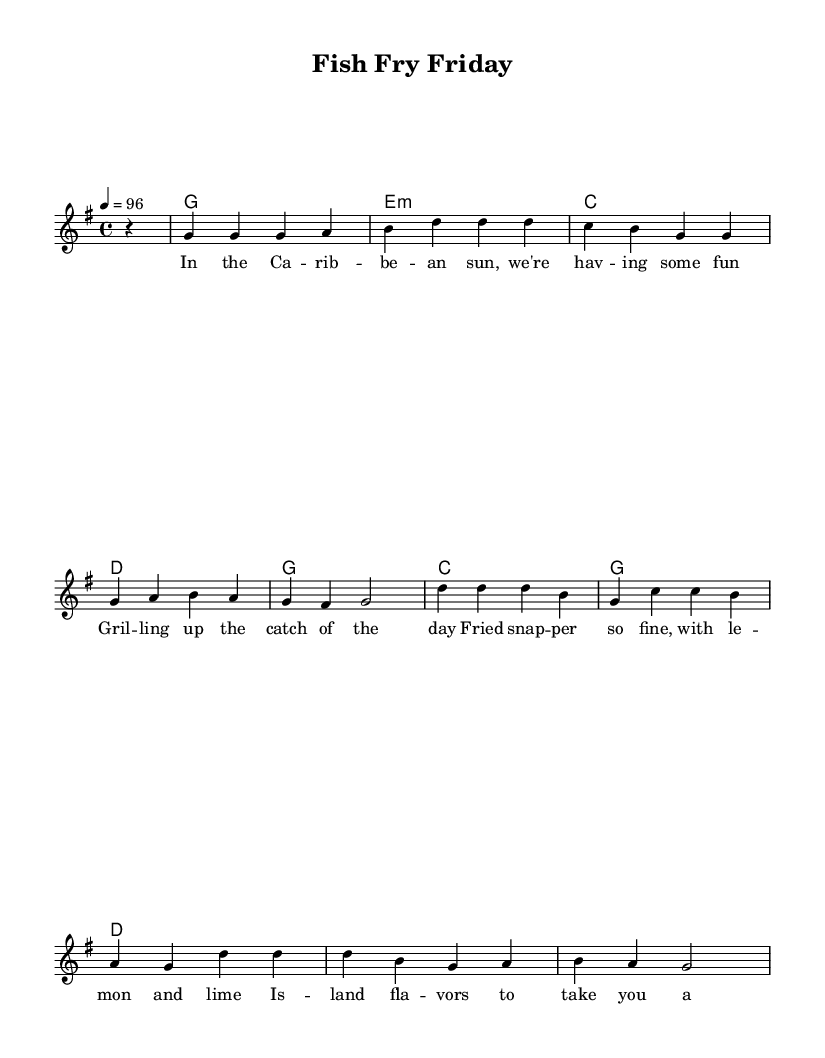What is the key signature of this music? The key signature shown at the beginning of the score is G major, which has one sharp (F#).
Answer: G major What is the time signature of this music? The time signature indicated at the beginning is 4/4, meaning there are four beats per measure and the quarter note gets one beat.
Answer: 4/4 What is the tempo of the piece? The tempo marking in the score states "4 = 96", which indicates the number of quarter note beats per minute.
Answer: 96 How many measures are in the melody? By counting the measures represented in the sheet music, there are a total of 8 measures in the melody section.
Answer: 8 What is the first chord in the score? The first chord listed in the chord names section is G major, which is indicated right after the initial rest.
Answer: G major What kind of fish dish is mentioned in the lyrics? The lyrics specifically mention "fried snapper," which is a traditional Caribbean fish dish highlighted in the song.
Answer: Fried snapper What overall theme is conveyed in the lyrics? The lyrics convey a celebration of Caribbean culinary traditions, specifically focused on enjoying fish dishes together in the sun.
Answer: Caribbean culinary traditions 